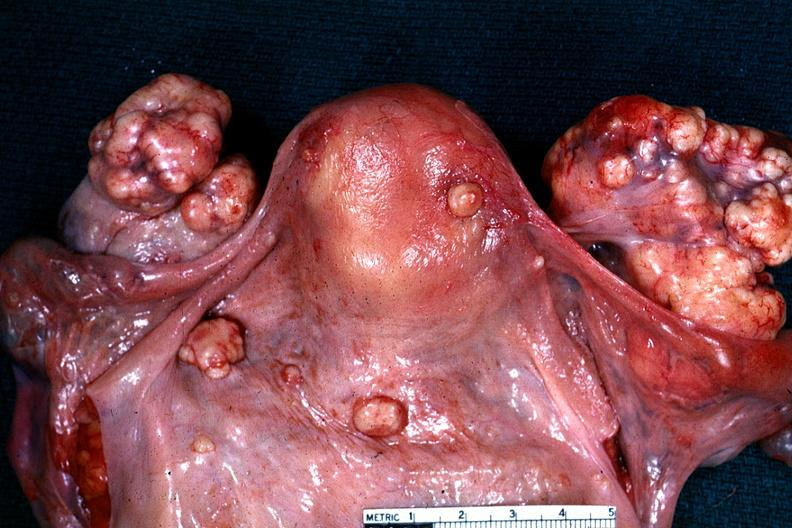what is present?
Answer the question using a single word or phrase. Metastatic carcinoma 